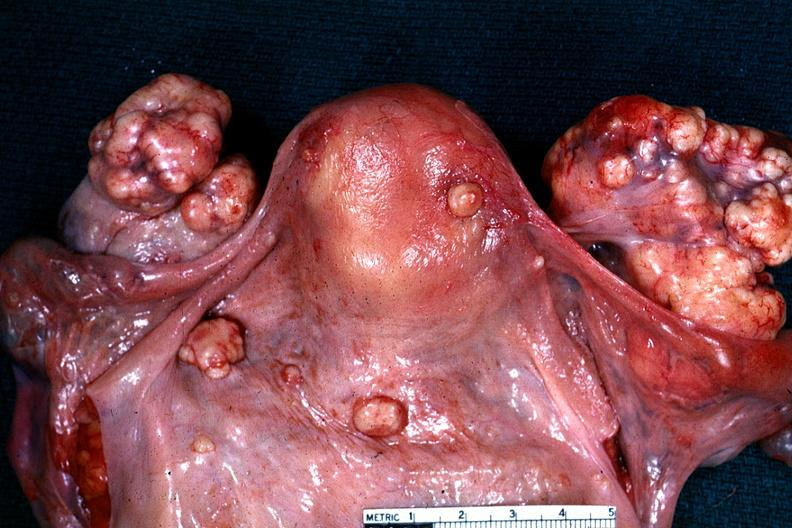what is present?
Answer the question using a single word or phrase. Metastatic carcinoma 